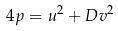Convert formula to latex. <formula><loc_0><loc_0><loc_500><loc_500>4 p = u ^ { 2 } + D v ^ { 2 }</formula> 